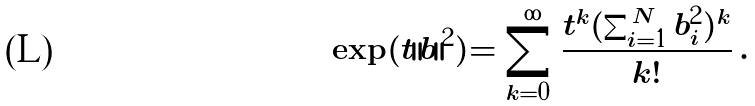<formula> <loc_0><loc_0><loc_500><loc_500>\exp ( t \| b \| ^ { 2 } ) = \sum _ { k = 0 } ^ { \infty } \frac { t ^ { k } ( \sum _ { i = 1 } ^ { N } b _ { i } ^ { 2 } ) ^ { k } } { k ! } \, .</formula> 